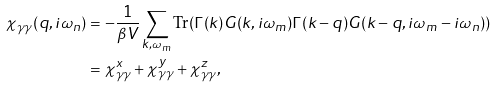Convert formula to latex. <formula><loc_0><loc_0><loc_500><loc_500>\chi _ { \gamma \gamma } ( q , i \omega _ { n } ) & = - \frac { 1 } { \beta V } \sum _ { k , \omega _ { m } } \text {Tr} ( \Gamma ( k ) G ( k , i \omega _ { m } ) \Gamma ( k - q ) G ( k - q , i \omega _ { m } - i \omega _ { n } ) ) \\ & = \chi _ { \gamma \gamma } ^ { x } + \chi _ { \gamma \gamma } ^ { y } + \chi _ { \gamma \gamma } ^ { z } ,</formula> 